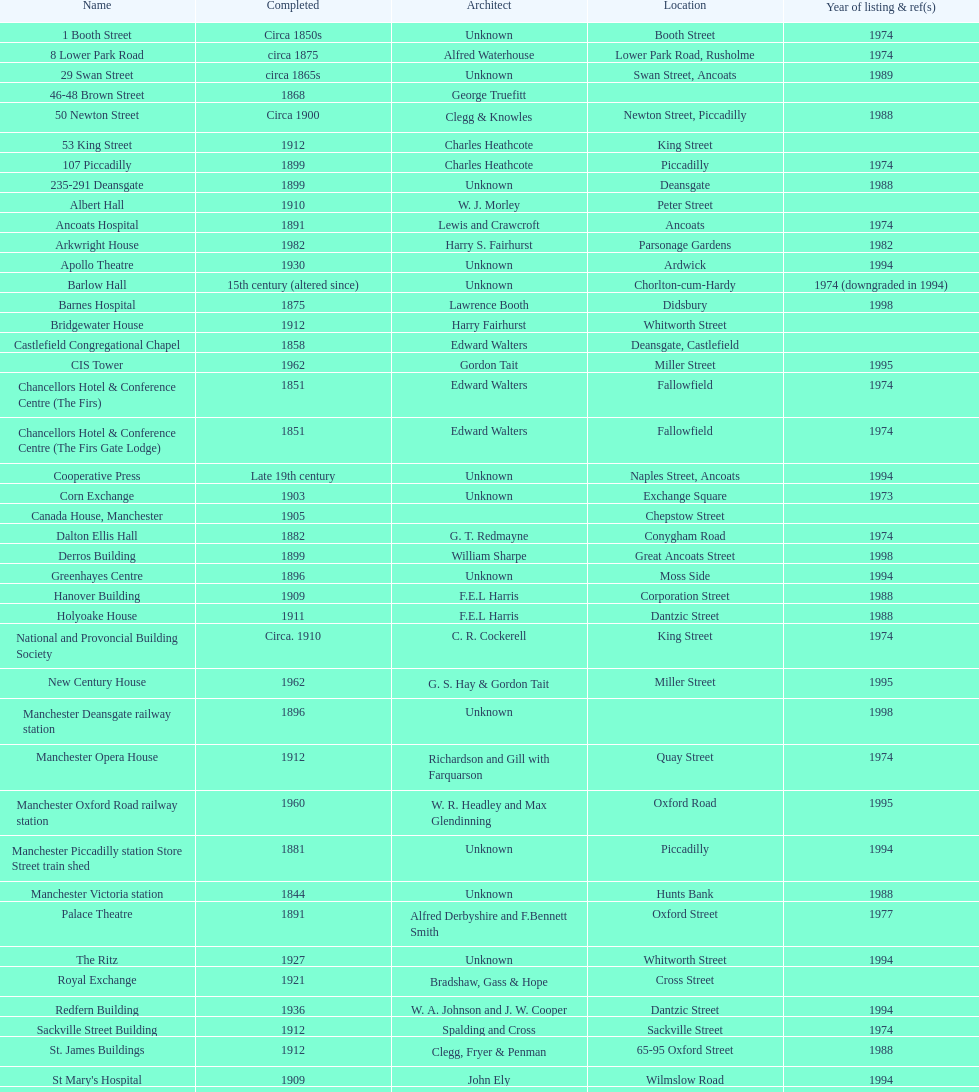What is the address of the sole building listed in 1989? Swan Street. 